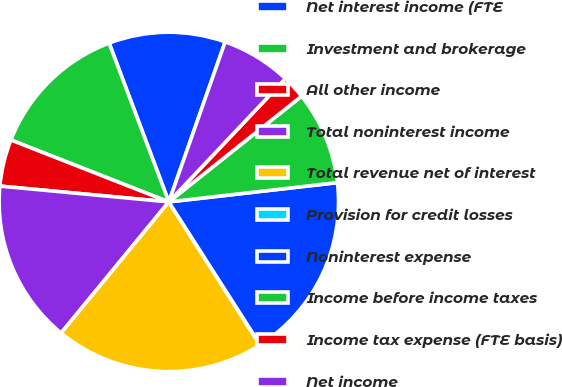<chart> <loc_0><loc_0><loc_500><loc_500><pie_chart><fcel>Net interest income (FTE<fcel>Investment and brokerage<fcel>All other income<fcel>Total noninterest income<fcel>Total revenue net of interest<fcel>Provision for credit losses<fcel>Noninterest expense<fcel>Income before income taxes<fcel>Income tax expense (FTE basis)<fcel>Net income<nl><fcel>11.11%<fcel>13.33%<fcel>4.46%<fcel>15.54%<fcel>19.98%<fcel>0.02%<fcel>17.76%<fcel>8.89%<fcel>2.24%<fcel>6.67%<nl></chart> 